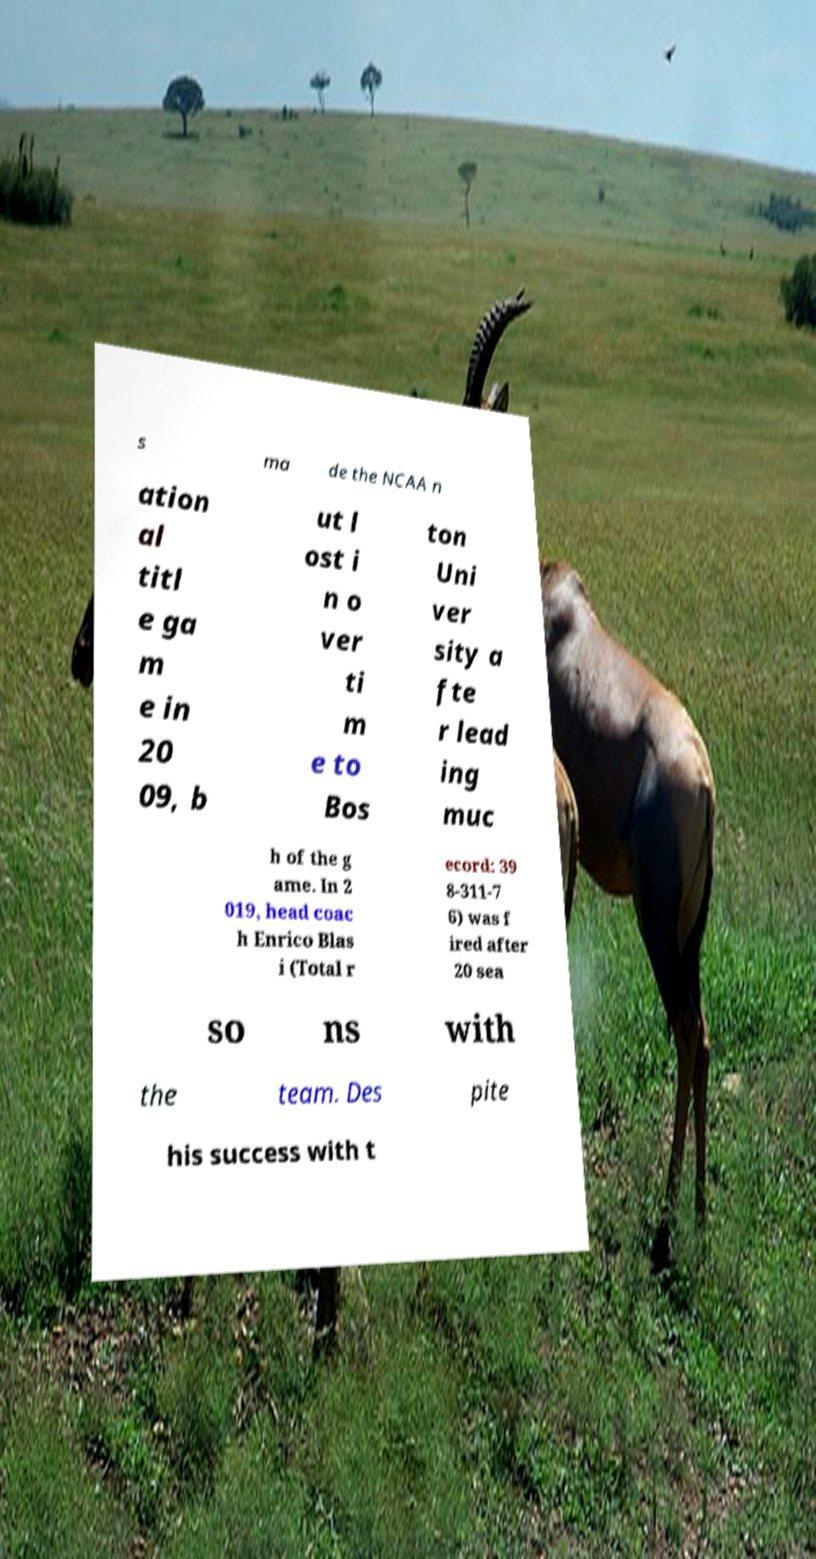For documentation purposes, I need the text within this image transcribed. Could you provide that? s ma de the NCAA n ation al titl e ga m e in 20 09, b ut l ost i n o ver ti m e to Bos ton Uni ver sity a fte r lead ing muc h of the g ame. In 2 019, head coac h Enrico Blas i (Total r ecord: 39 8-311-7 6) was f ired after 20 sea so ns with the team. Des pite his success with t 